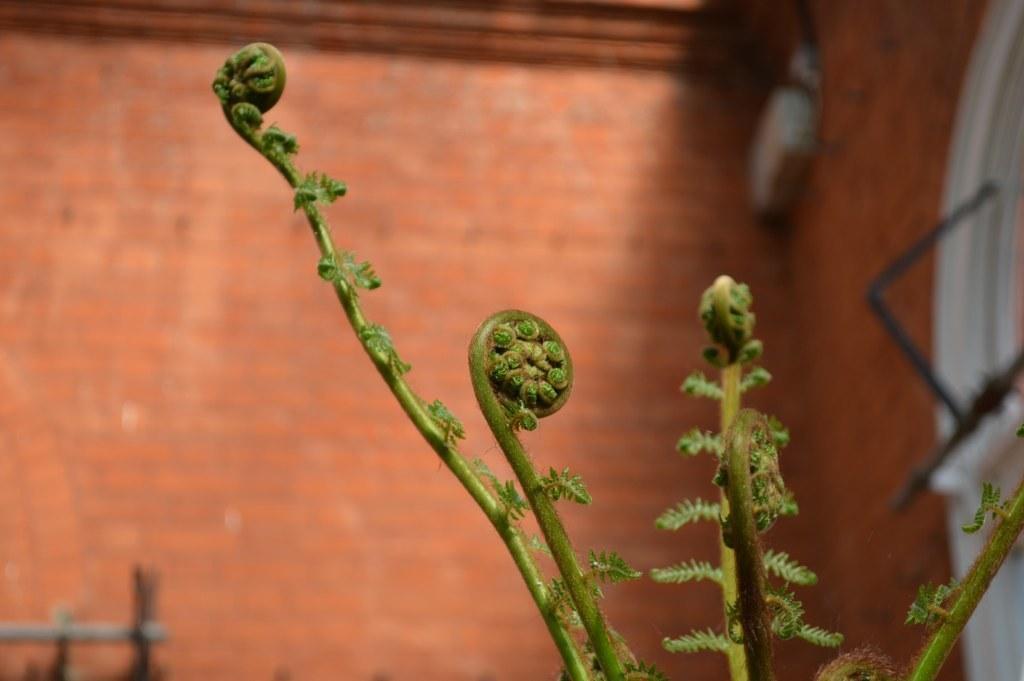Please provide a concise description of this image. In this image at front there is a plant and at the back side there is a wall. 